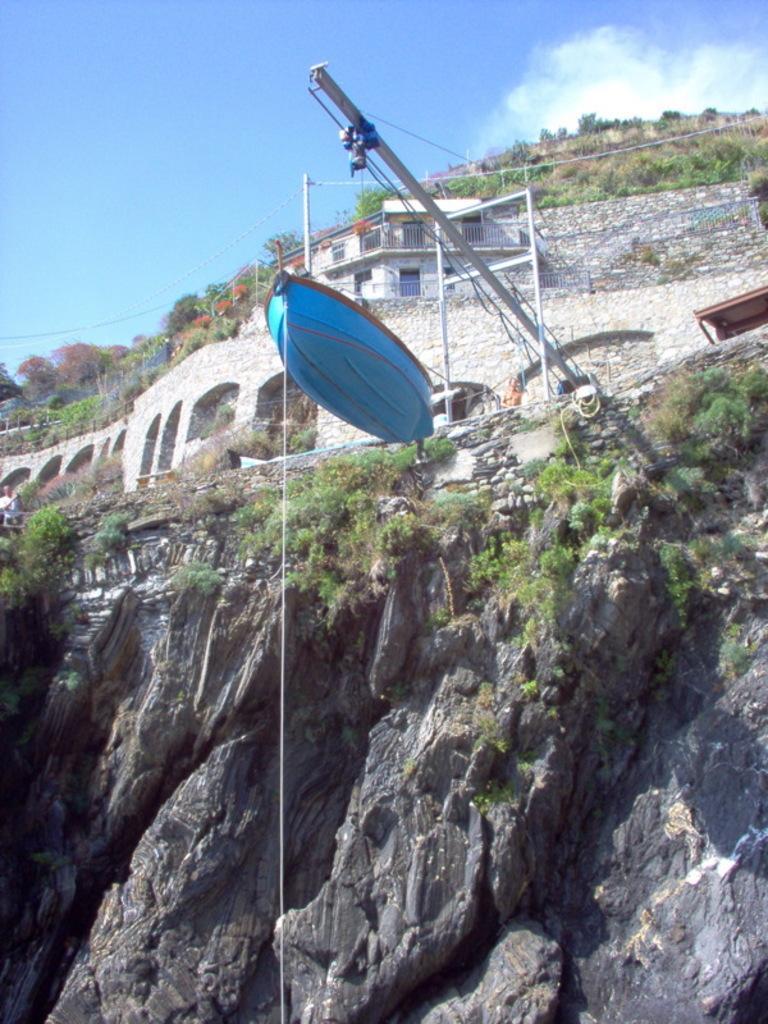In one or two sentences, can you explain what this image depicts? In the center of the image there is a blue color boat. In the background of the image there is a mountain on which there is a house. At the top of the image there is sky. 